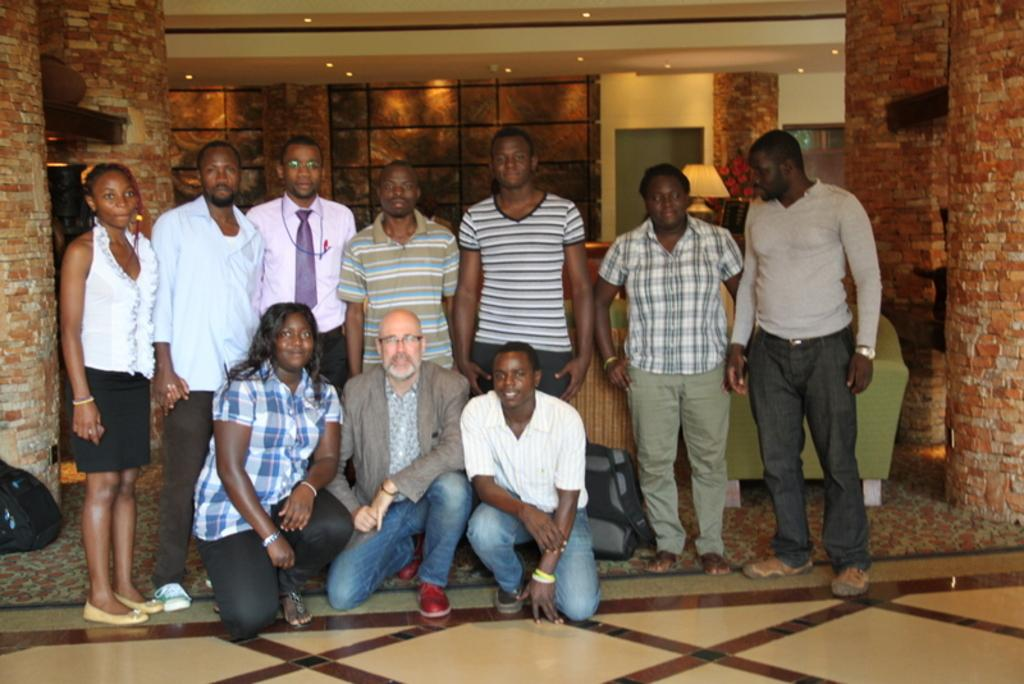What are the people in the image doing? Some people are standing, while others are sitting in the image. What architectural feature can be seen in the image? There are pillars visible in the image. What surface are the people standing or sitting on? There is a floor visible in the image. How many chairs are there in the image? There are no chairs present in the image. What type of flight is being taken by the people in the image? There is no flight or indication of travel in the image; it simply shows people standing and sitting. 